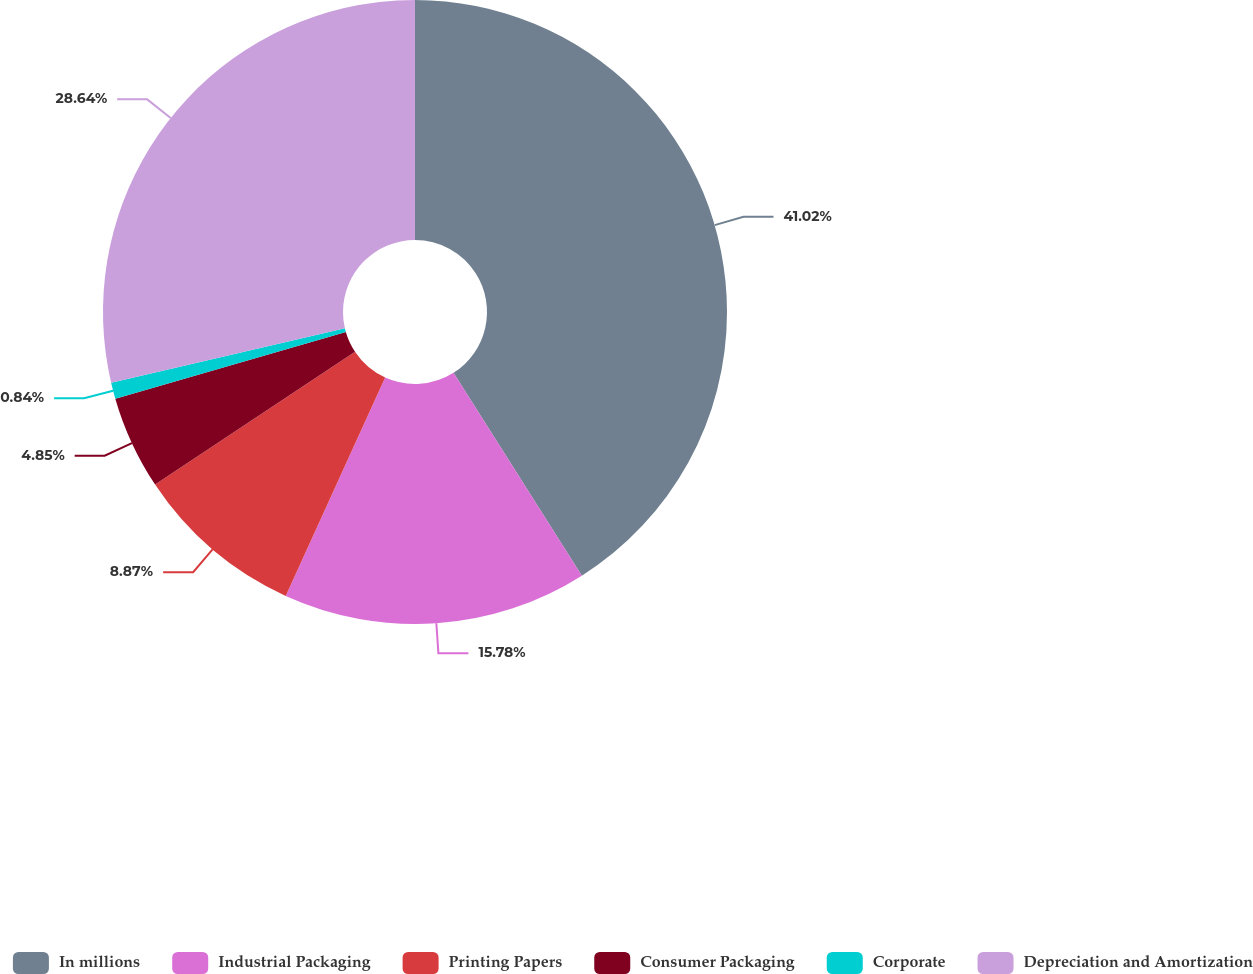<chart> <loc_0><loc_0><loc_500><loc_500><pie_chart><fcel>In millions<fcel>Industrial Packaging<fcel>Printing Papers<fcel>Consumer Packaging<fcel>Corporate<fcel>Depreciation and Amortization<nl><fcel>41.02%<fcel>15.78%<fcel>8.87%<fcel>4.85%<fcel>0.84%<fcel>28.64%<nl></chart> 